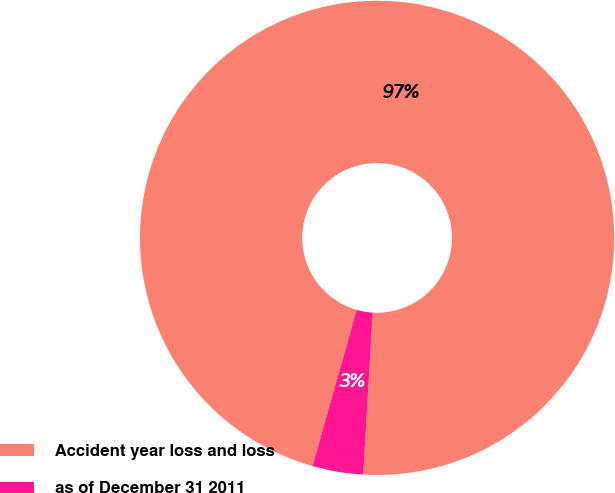Convert chart. <chart><loc_0><loc_0><loc_500><loc_500><pie_chart><fcel>Accident year loss and loss<fcel>as of December 31 2011<nl><fcel>96.54%<fcel>3.46%<nl></chart> 